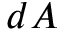<formula> <loc_0><loc_0><loc_500><loc_500>d A</formula> 